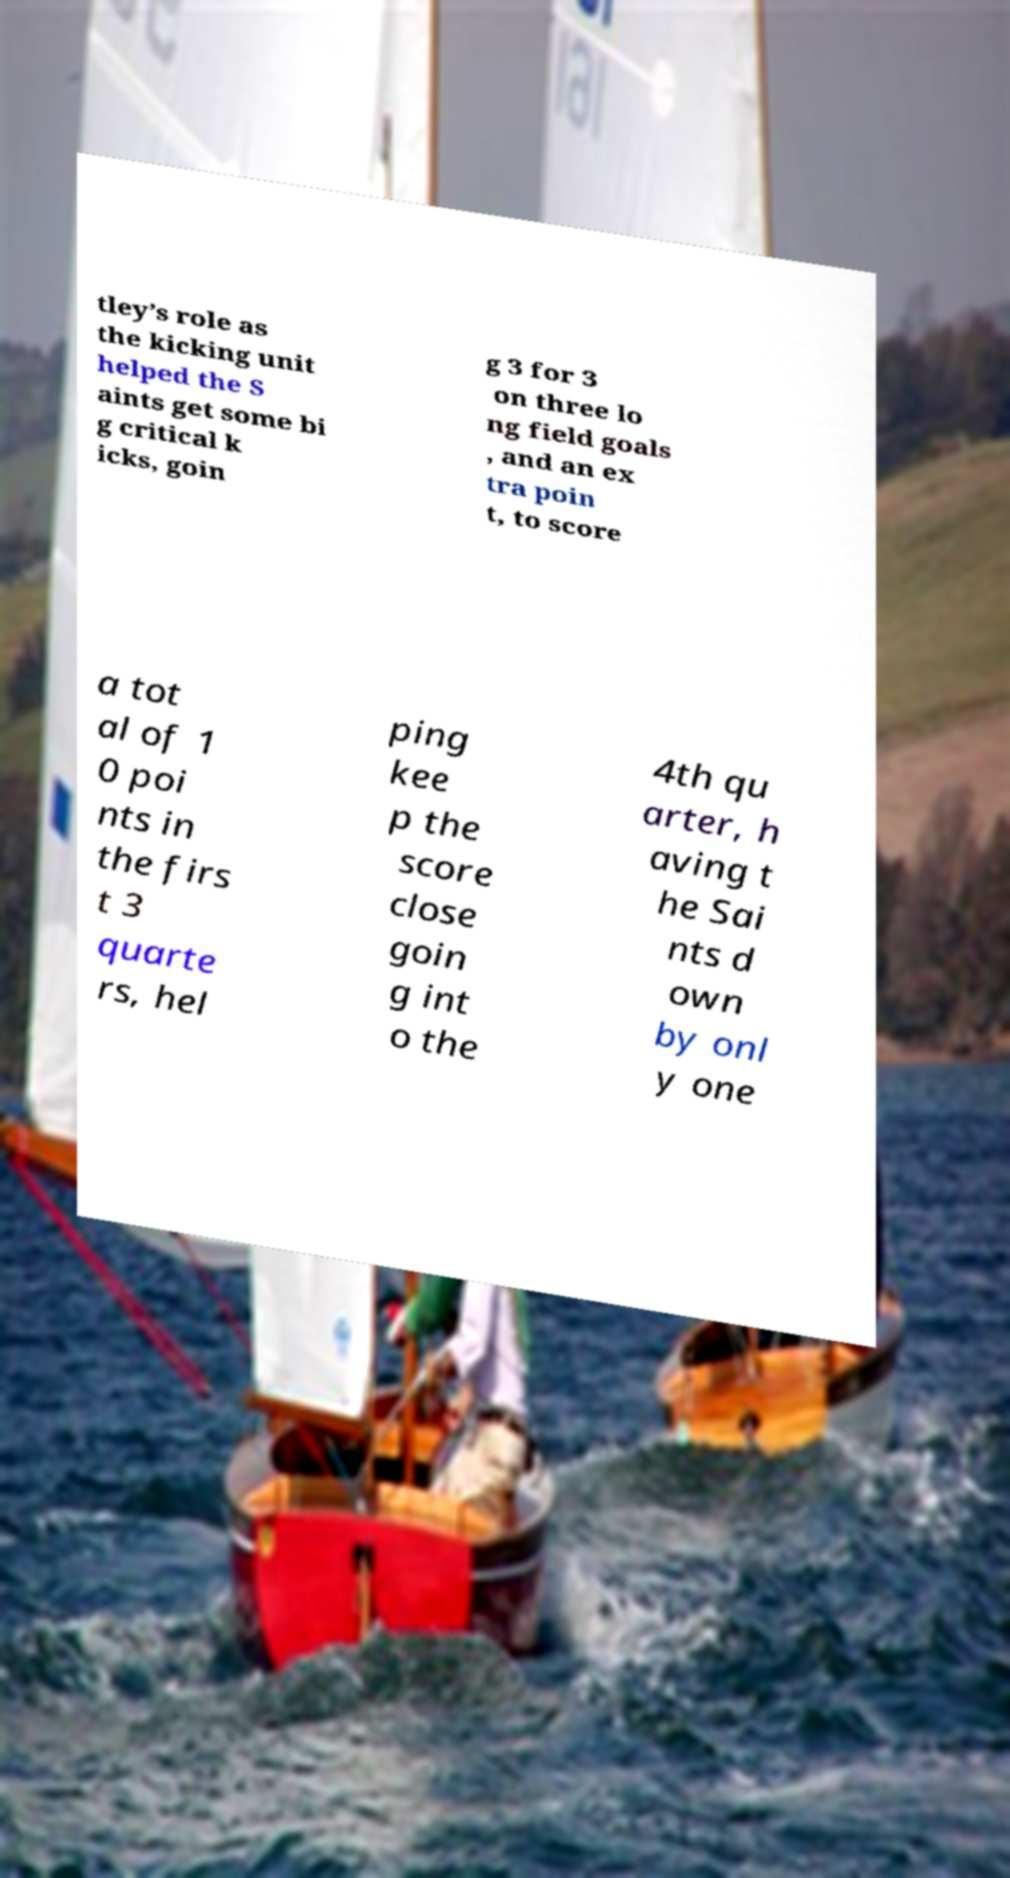I need the written content from this picture converted into text. Can you do that? tley’s role as the kicking unit helped the S aints get some bi g critical k icks, goin g 3 for 3 on three lo ng field goals , and an ex tra poin t, to score a tot al of 1 0 poi nts in the firs t 3 quarte rs, hel ping kee p the score close goin g int o the 4th qu arter, h aving t he Sai nts d own by onl y one 